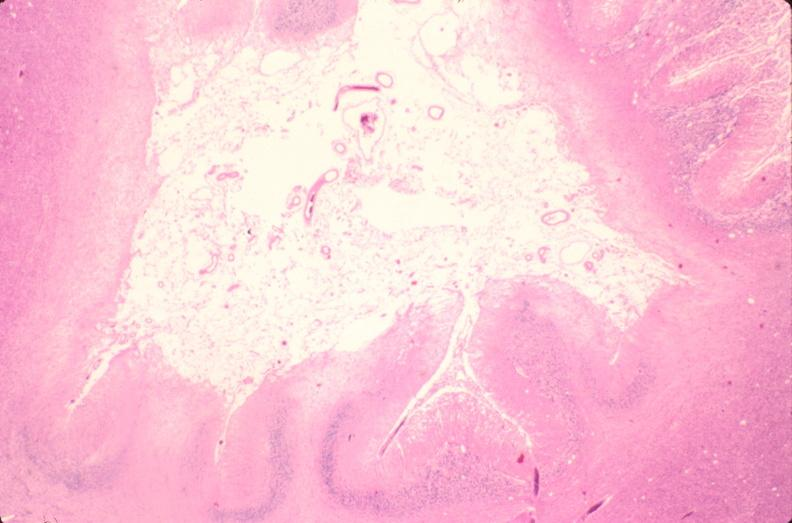s nervous present?
Answer the question using a single word or phrase. Yes 